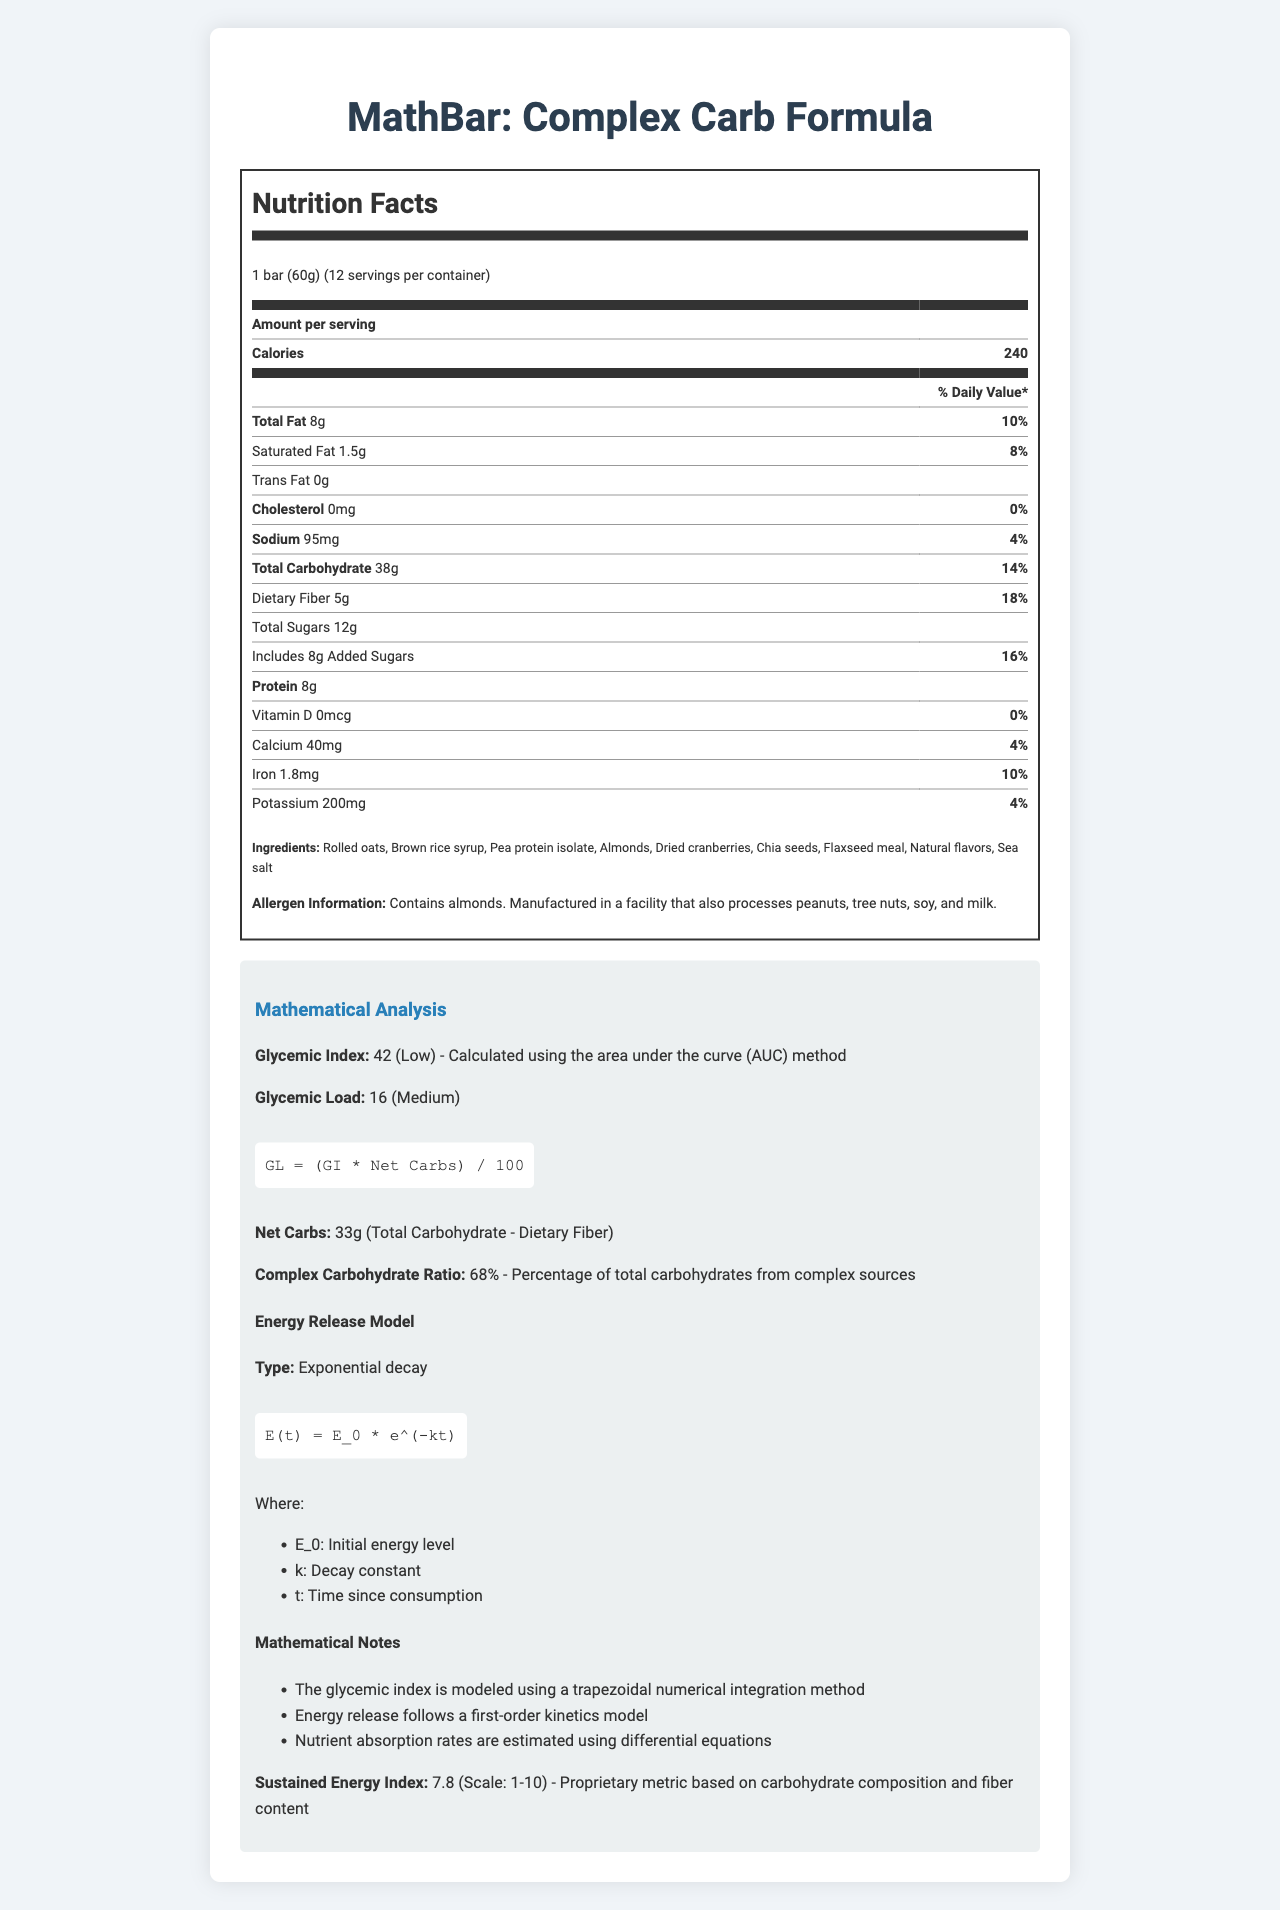what is the serving size? The serving size is directly stated in the document as "1 bar (60g)".
Answer: 1 bar (60g) how many calories are in one serving? According to the document, one serving contains 240 calories.
Answer: 240 what is the total carbohydrate content per serving? The total carbohydrate per serving is listed as 38g in the document.
Answer: 38g how much dietary fiber is in one serving, and what percentage of the daily value does it provide? The dietary fiber per serving is 5g, which provides 18% of the daily value as stated in the document.
Answer: 5g, 18% what is the glycemic index of the MathBar? The document specifies the glycemic index of the MathBar as 42.
Answer: 42 what is the main source of protein in the MathBar? A. Almonds B. Rolled oats C. Pea protein isolate D. Chia seeds Among the listed ingredients, pea protein isolate is a primary source of protein.
Answer: C. Pea protein isolate what type of energy release model is used to describe the MathBar? A. Linear B. Exponential decay C. Logistic growth D. Polynomial The document highlights that the energy release model employed is an exponential decay model.
Answer: B. Exponential decay does the MathBar contain any trans fat? The document explicitly states that the MathBar contains 0g of trans fat.
Answer: No is the MathBar suitable for individuals with almond allergies? The allergen information in the document mentions that the MathBar contains almonds, making it unsuitable for individuals with almond allergies.
Answer: No what is the duration of the MathBar's shelf life? The shelf life of the MathBar is stated to be 12 months in the document.
Answer: 12 months what are the key mathematical models mentioned in the document? The document mentions the mathematical models used, including trapezoidal numerical integration for glycemic index, first-order kinetics for energy release, differential equations for nutrient absorption, and the Arrhenius equation for shelf life prediction.
Answer: Trapezoidal numerical integration, first-order kinetics, differential equations, Arrhenius equation how is the complex carbohydrate ratio described? The document explains that the complex carbohydrate ratio is 68%, representing the percentage of total carbohydrates derived from complex sources.
Answer: 68%, percentage of total carbohydrates from complex sources can the exact manufacturing process be determined from the document? The document does not provide details on the exact manufacturing process; it only lists the ingredients and allergen information.
Answer: No please summarize the main elements of the nutrition facts and mathematical analysis of the MathBar. The MathBar is a complex carbohydrate energy bar designed with nutritional and mathematical insights, focusing on providing sustained energy release through a combination of carbohydrates, proteins, and fiber. The glycemic index and load indicate moderate blood sugar impact, and its energy release follows exponential decay to simulate prolonged energy supply. Additionally, the document describes various mathematical models used to analyze its nutritional and storage properties.
Answer: The MathBar provides 240 calories per serving with 38g of total carbs, 5g of dietary fiber, and 8g of protein. It has a glycemic index of 42 (low) and a glycemic load of 16 (medium), with a complex carbohydrate ratio of 68%. The energy release follows an exponential decay model, and the document includes mathematical notes on energy release and nutrient absorption models. 